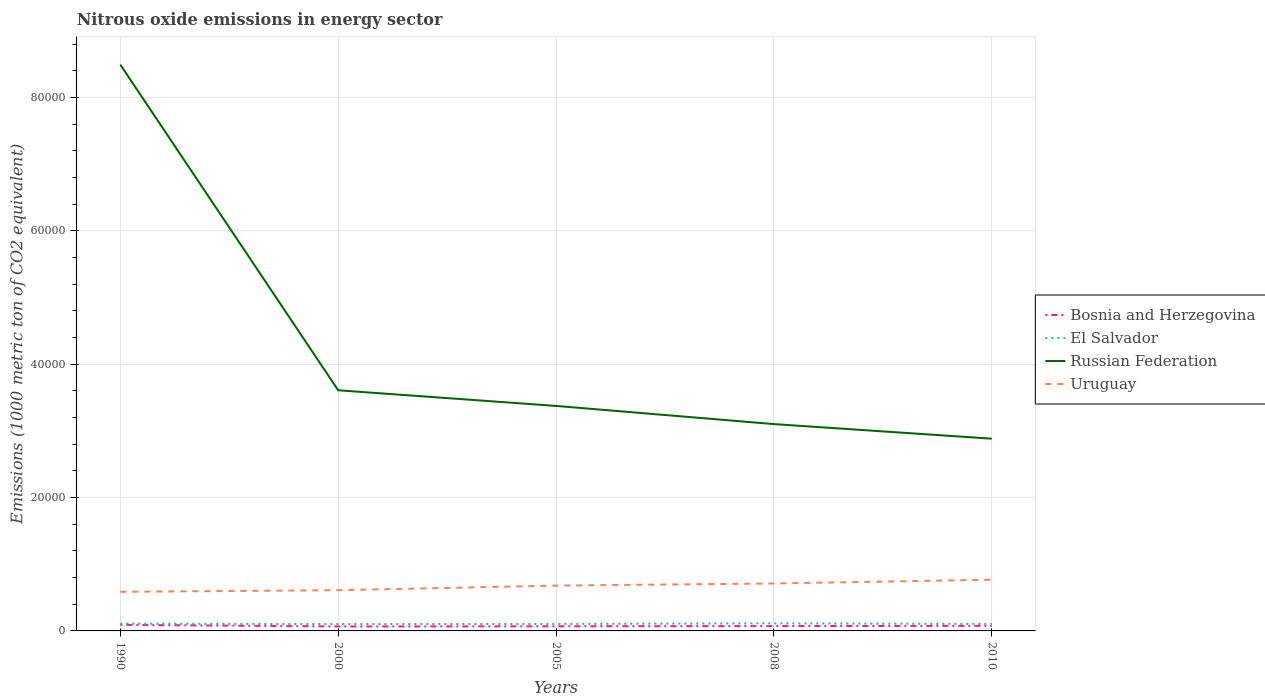Does the line corresponding to El Salvador intersect with the line corresponding to Bosnia and Herzegovina?
Provide a succinct answer. No. Across all years, what is the maximum amount of nitrous oxide emitted in El Salvador?
Ensure brevity in your answer.  1028. In which year was the amount of nitrous oxide emitted in Uruguay maximum?
Provide a succinct answer. 1990. What is the total amount of nitrous oxide emitted in Russian Federation in the graph?
Your response must be concise. 4.88e+04. What is the difference between the highest and the second highest amount of nitrous oxide emitted in El Salvador?
Provide a short and direct response. 107. How many lines are there?
Your response must be concise. 4. Does the graph contain any zero values?
Keep it short and to the point. No. What is the title of the graph?
Provide a short and direct response. Nitrous oxide emissions in energy sector. What is the label or title of the X-axis?
Provide a short and direct response. Years. What is the label or title of the Y-axis?
Keep it short and to the point. Emissions (1000 metric ton of CO2 equivalent). What is the Emissions (1000 metric ton of CO2 equivalent) of Bosnia and Herzegovina in 1990?
Offer a terse response. 912.2. What is the Emissions (1000 metric ton of CO2 equivalent) in El Salvador in 1990?
Provide a short and direct response. 1088.8. What is the Emissions (1000 metric ton of CO2 equivalent) of Russian Federation in 1990?
Keep it short and to the point. 8.49e+04. What is the Emissions (1000 metric ton of CO2 equivalent) of Uruguay in 1990?
Provide a short and direct response. 5867.6. What is the Emissions (1000 metric ton of CO2 equivalent) in Bosnia and Herzegovina in 2000?
Offer a very short reply. 669.3. What is the Emissions (1000 metric ton of CO2 equivalent) of El Salvador in 2000?
Ensure brevity in your answer.  1028. What is the Emissions (1000 metric ton of CO2 equivalent) of Russian Federation in 2000?
Your response must be concise. 3.61e+04. What is the Emissions (1000 metric ton of CO2 equivalent) in Uruguay in 2000?
Ensure brevity in your answer.  6109. What is the Emissions (1000 metric ton of CO2 equivalent) in Bosnia and Herzegovina in 2005?
Ensure brevity in your answer.  691.3. What is the Emissions (1000 metric ton of CO2 equivalent) in El Salvador in 2005?
Make the answer very short. 1049.1. What is the Emissions (1000 metric ton of CO2 equivalent) in Russian Federation in 2005?
Provide a succinct answer. 3.37e+04. What is the Emissions (1000 metric ton of CO2 equivalent) in Uruguay in 2005?
Offer a very short reply. 6798.2. What is the Emissions (1000 metric ton of CO2 equivalent) in Bosnia and Herzegovina in 2008?
Your response must be concise. 727.1. What is the Emissions (1000 metric ton of CO2 equivalent) of El Salvador in 2008?
Your answer should be compact. 1135. What is the Emissions (1000 metric ton of CO2 equivalent) of Russian Federation in 2008?
Provide a short and direct response. 3.10e+04. What is the Emissions (1000 metric ton of CO2 equivalent) in Uruguay in 2008?
Your answer should be compact. 7116. What is the Emissions (1000 metric ton of CO2 equivalent) in Bosnia and Herzegovina in 2010?
Offer a terse response. 762.6. What is the Emissions (1000 metric ton of CO2 equivalent) of El Salvador in 2010?
Make the answer very short. 1044.8. What is the Emissions (1000 metric ton of CO2 equivalent) of Russian Federation in 2010?
Your answer should be very brief. 2.88e+04. What is the Emissions (1000 metric ton of CO2 equivalent) in Uruguay in 2010?
Offer a very short reply. 7685.3. Across all years, what is the maximum Emissions (1000 metric ton of CO2 equivalent) in Bosnia and Herzegovina?
Ensure brevity in your answer.  912.2. Across all years, what is the maximum Emissions (1000 metric ton of CO2 equivalent) in El Salvador?
Make the answer very short. 1135. Across all years, what is the maximum Emissions (1000 metric ton of CO2 equivalent) of Russian Federation?
Provide a short and direct response. 8.49e+04. Across all years, what is the maximum Emissions (1000 metric ton of CO2 equivalent) of Uruguay?
Your answer should be compact. 7685.3. Across all years, what is the minimum Emissions (1000 metric ton of CO2 equivalent) of Bosnia and Herzegovina?
Your answer should be compact. 669.3. Across all years, what is the minimum Emissions (1000 metric ton of CO2 equivalent) of El Salvador?
Keep it short and to the point. 1028. Across all years, what is the minimum Emissions (1000 metric ton of CO2 equivalent) of Russian Federation?
Provide a succinct answer. 2.88e+04. Across all years, what is the minimum Emissions (1000 metric ton of CO2 equivalent) of Uruguay?
Offer a very short reply. 5867.6. What is the total Emissions (1000 metric ton of CO2 equivalent) in Bosnia and Herzegovina in the graph?
Give a very brief answer. 3762.5. What is the total Emissions (1000 metric ton of CO2 equivalent) of El Salvador in the graph?
Provide a succinct answer. 5345.7. What is the total Emissions (1000 metric ton of CO2 equivalent) in Russian Federation in the graph?
Your answer should be compact. 2.15e+05. What is the total Emissions (1000 metric ton of CO2 equivalent) of Uruguay in the graph?
Your response must be concise. 3.36e+04. What is the difference between the Emissions (1000 metric ton of CO2 equivalent) in Bosnia and Herzegovina in 1990 and that in 2000?
Ensure brevity in your answer.  242.9. What is the difference between the Emissions (1000 metric ton of CO2 equivalent) in El Salvador in 1990 and that in 2000?
Give a very brief answer. 60.8. What is the difference between the Emissions (1000 metric ton of CO2 equivalent) in Russian Federation in 1990 and that in 2000?
Keep it short and to the point. 4.88e+04. What is the difference between the Emissions (1000 metric ton of CO2 equivalent) of Uruguay in 1990 and that in 2000?
Provide a succinct answer. -241.4. What is the difference between the Emissions (1000 metric ton of CO2 equivalent) of Bosnia and Herzegovina in 1990 and that in 2005?
Keep it short and to the point. 220.9. What is the difference between the Emissions (1000 metric ton of CO2 equivalent) in El Salvador in 1990 and that in 2005?
Make the answer very short. 39.7. What is the difference between the Emissions (1000 metric ton of CO2 equivalent) in Russian Federation in 1990 and that in 2005?
Ensure brevity in your answer.  5.12e+04. What is the difference between the Emissions (1000 metric ton of CO2 equivalent) in Uruguay in 1990 and that in 2005?
Keep it short and to the point. -930.6. What is the difference between the Emissions (1000 metric ton of CO2 equivalent) of Bosnia and Herzegovina in 1990 and that in 2008?
Ensure brevity in your answer.  185.1. What is the difference between the Emissions (1000 metric ton of CO2 equivalent) of El Salvador in 1990 and that in 2008?
Your answer should be compact. -46.2. What is the difference between the Emissions (1000 metric ton of CO2 equivalent) of Russian Federation in 1990 and that in 2008?
Offer a terse response. 5.39e+04. What is the difference between the Emissions (1000 metric ton of CO2 equivalent) in Uruguay in 1990 and that in 2008?
Your answer should be compact. -1248.4. What is the difference between the Emissions (1000 metric ton of CO2 equivalent) of Bosnia and Herzegovina in 1990 and that in 2010?
Your answer should be very brief. 149.6. What is the difference between the Emissions (1000 metric ton of CO2 equivalent) in El Salvador in 1990 and that in 2010?
Ensure brevity in your answer.  44. What is the difference between the Emissions (1000 metric ton of CO2 equivalent) of Russian Federation in 1990 and that in 2010?
Keep it short and to the point. 5.61e+04. What is the difference between the Emissions (1000 metric ton of CO2 equivalent) in Uruguay in 1990 and that in 2010?
Offer a very short reply. -1817.7. What is the difference between the Emissions (1000 metric ton of CO2 equivalent) in Bosnia and Herzegovina in 2000 and that in 2005?
Provide a short and direct response. -22. What is the difference between the Emissions (1000 metric ton of CO2 equivalent) in El Salvador in 2000 and that in 2005?
Keep it short and to the point. -21.1. What is the difference between the Emissions (1000 metric ton of CO2 equivalent) in Russian Federation in 2000 and that in 2005?
Your response must be concise. 2347.2. What is the difference between the Emissions (1000 metric ton of CO2 equivalent) in Uruguay in 2000 and that in 2005?
Your answer should be compact. -689.2. What is the difference between the Emissions (1000 metric ton of CO2 equivalent) of Bosnia and Herzegovina in 2000 and that in 2008?
Offer a terse response. -57.8. What is the difference between the Emissions (1000 metric ton of CO2 equivalent) of El Salvador in 2000 and that in 2008?
Ensure brevity in your answer.  -107. What is the difference between the Emissions (1000 metric ton of CO2 equivalent) in Russian Federation in 2000 and that in 2008?
Give a very brief answer. 5072.4. What is the difference between the Emissions (1000 metric ton of CO2 equivalent) of Uruguay in 2000 and that in 2008?
Offer a terse response. -1007. What is the difference between the Emissions (1000 metric ton of CO2 equivalent) of Bosnia and Herzegovina in 2000 and that in 2010?
Your response must be concise. -93.3. What is the difference between the Emissions (1000 metric ton of CO2 equivalent) in El Salvador in 2000 and that in 2010?
Offer a terse response. -16.8. What is the difference between the Emissions (1000 metric ton of CO2 equivalent) in Russian Federation in 2000 and that in 2010?
Keep it short and to the point. 7261.9. What is the difference between the Emissions (1000 metric ton of CO2 equivalent) of Uruguay in 2000 and that in 2010?
Make the answer very short. -1576.3. What is the difference between the Emissions (1000 metric ton of CO2 equivalent) of Bosnia and Herzegovina in 2005 and that in 2008?
Your answer should be very brief. -35.8. What is the difference between the Emissions (1000 metric ton of CO2 equivalent) in El Salvador in 2005 and that in 2008?
Make the answer very short. -85.9. What is the difference between the Emissions (1000 metric ton of CO2 equivalent) in Russian Federation in 2005 and that in 2008?
Provide a succinct answer. 2725.2. What is the difference between the Emissions (1000 metric ton of CO2 equivalent) of Uruguay in 2005 and that in 2008?
Provide a succinct answer. -317.8. What is the difference between the Emissions (1000 metric ton of CO2 equivalent) in Bosnia and Herzegovina in 2005 and that in 2010?
Offer a terse response. -71.3. What is the difference between the Emissions (1000 metric ton of CO2 equivalent) of Russian Federation in 2005 and that in 2010?
Your response must be concise. 4914.7. What is the difference between the Emissions (1000 metric ton of CO2 equivalent) in Uruguay in 2005 and that in 2010?
Keep it short and to the point. -887.1. What is the difference between the Emissions (1000 metric ton of CO2 equivalent) in Bosnia and Herzegovina in 2008 and that in 2010?
Provide a succinct answer. -35.5. What is the difference between the Emissions (1000 metric ton of CO2 equivalent) in El Salvador in 2008 and that in 2010?
Keep it short and to the point. 90.2. What is the difference between the Emissions (1000 metric ton of CO2 equivalent) in Russian Federation in 2008 and that in 2010?
Your answer should be very brief. 2189.5. What is the difference between the Emissions (1000 metric ton of CO2 equivalent) in Uruguay in 2008 and that in 2010?
Keep it short and to the point. -569.3. What is the difference between the Emissions (1000 metric ton of CO2 equivalent) of Bosnia and Herzegovina in 1990 and the Emissions (1000 metric ton of CO2 equivalent) of El Salvador in 2000?
Provide a succinct answer. -115.8. What is the difference between the Emissions (1000 metric ton of CO2 equivalent) in Bosnia and Herzegovina in 1990 and the Emissions (1000 metric ton of CO2 equivalent) in Russian Federation in 2000?
Provide a short and direct response. -3.52e+04. What is the difference between the Emissions (1000 metric ton of CO2 equivalent) in Bosnia and Herzegovina in 1990 and the Emissions (1000 metric ton of CO2 equivalent) in Uruguay in 2000?
Make the answer very short. -5196.8. What is the difference between the Emissions (1000 metric ton of CO2 equivalent) in El Salvador in 1990 and the Emissions (1000 metric ton of CO2 equivalent) in Russian Federation in 2000?
Ensure brevity in your answer.  -3.50e+04. What is the difference between the Emissions (1000 metric ton of CO2 equivalent) of El Salvador in 1990 and the Emissions (1000 metric ton of CO2 equivalent) of Uruguay in 2000?
Provide a short and direct response. -5020.2. What is the difference between the Emissions (1000 metric ton of CO2 equivalent) in Russian Federation in 1990 and the Emissions (1000 metric ton of CO2 equivalent) in Uruguay in 2000?
Make the answer very short. 7.88e+04. What is the difference between the Emissions (1000 metric ton of CO2 equivalent) of Bosnia and Herzegovina in 1990 and the Emissions (1000 metric ton of CO2 equivalent) of El Salvador in 2005?
Offer a terse response. -136.9. What is the difference between the Emissions (1000 metric ton of CO2 equivalent) of Bosnia and Herzegovina in 1990 and the Emissions (1000 metric ton of CO2 equivalent) of Russian Federation in 2005?
Provide a short and direct response. -3.28e+04. What is the difference between the Emissions (1000 metric ton of CO2 equivalent) of Bosnia and Herzegovina in 1990 and the Emissions (1000 metric ton of CO2 equivalent) of Uruguay in 2005?
Your response must be concise. -5886. What is the difference between the Emissions (1000 metric ton of CO2 equivalent) of El Salvador in 1990 and the Emissions (1000 metric ton of CO2 equivalent) of Russian Federation in 2005?
Your answer should be very brief. -3.27e+04. What is the difference between the Emissions (1000 metric ton of CO2 equivalent) in El Salvador in 1990 and the Emissions (1000 metric ton of CO2 equivalent) in Uruguay in 2005?
Provide a short and direct response. -5709.4. What is the difference between the Emissions (1000 metric ton of CO2 equivalent) in Russian Federation in 1990 and the Emissions (1000 metric ton of CO2 equivalent) in Uruguay in 2005?
Give a very brief answer. 7.81e+04. What is the difference between the Emissions (1000 metric ton of CO2 equivalent) in Bosnia and Herzegovina in 1990 and the Emissions (1000 metric ton of CO2 equivalent) in El Salvador in 2008?
Your response must be concise. -222.8. What is the difference between the Emissions (1000 metric ton of CO2 equivalent) in Bosnia and Herzegovina in 1990 and the Emissions (1000 metric ton of CO2 equivalent) in Russian Federation in 2008?
Ensure brevity in your answer.  -3.01e+04. What is the difference between the Emissions (1000 metric ton of CO2 equivalent) of Bosnia and Herzegovina in 1990 and the Emissions (1000 metric ton of CO2 equivalent) of Uruguay in 2008?
Offer a terse response. -6203.8. What is the difference between the Emissions (1000 metric ton of CO2 equivalent) of El Salvador in 1990 and the Emissions (1000 metric ton of CO2 equivalent) of Russian Federation in 2008?
Provide a succinct answer. -2.99e+04. What is the difference between the Emissions (1000 metric ton of CO2 equivalent) of El Salvador in 1990 and the Emissions (1000 metric ton of CO2 equivalent) of Uruguay in 2008?
Keep it short and to the point. -6027.2. What is the difference between the Emissions (1000 metric ton of CO2 equivalent) of Russian Federation in 1990 and the Emissions (1000 metric ton of CO2 equivalent) of Uruguay in 2008?
Your answer should be compact. 7.78e+04. What is the difference between the Emissions (1000 metric ton of CO2 equivalent) of Bosnia and Herzegovina in 1990 and the Emissions (1000 metric ton of CO2 equivalent) of El Salvador in 2010?
Offer a very short reply. -132.6. What is the difference between the Emissions (1000 metric ton of CO2 equivalent) of Bosnia and Herzegovina in 1990 and the Emissions (1000 metric ton of CO2 equivalent) of Russian Federation in 2010?
Your answer should be compact. -2.79e+04. What is the difference between the Emissions (1000 metric ton of CO2 equivalent) in Bosnia and Herzegovina in 1990 and the Emissions (1000 metric ton of CO2 equivalent) in Uruguay in 2010?
Provide a succinct answer. -6773.1. What is the difference between the Emissions (1000 metric ton of CO2 equivalent) in El Salvador in 1990 and the Emissions (1000 metric ton of CO2 equivalent) in Russian Federation in 2010?
Make the answer very short. -2.77e+04. What is the difference between the Emissions (1000 metric ton of CO2 equivalent) in El Salvador in 1990 and the Emissions (1000 metric ton of CO2 equivalent) in Uruguay in 2010?
Your response must be concise. -6596.5. What is the difference between the Emissions (1000 metric ton of CO2 equivalent) of Russian Federation in 1990 and the Emissions (1000 metric ton of CO2 equivalent) of Uruguay in 2010?
Offer a terse response. 7.73e+04. What is the difference between the Emissions (1000 metric ton of CO2 equivalent) in Bosnia and Herzegovina in 2000 and the Emissions (1000 metric ton of CO2 equivalent) in El Salvador in 2005?
Provide a short and direct response. -379.8. What is the difference between the Emissions (1000 metric ton of CO2 equivalent) in Bosnia and Herzegovina in 2000 and the Emissions (1000 metric ton of CO2 equivalent) in Russian Federation in 2005?
Make the answer very short. -3.31e+04. What is the difference between the Emissions (1000 metric ton of CO2 equivalent) in Bosnia and Herzegovina in 2000 and the Emissions (1000 metric ton of CO2 equivalent) in Uruguay in 2005?
Ensure brevity in your answer.  -6128.9. What is the difference between the Emissions (1000 metric ton of CO2 equivalent) of El Salvador in 2000 and the Emissions (1000 metric ton of CO2 equivalent) of Russian Federation in 2005?
Keep it short and to the point. -3.27e+04. What is the difference between the Emissions (1000 metric ton of CO2 equivalent) in El Salvador in 2000 and the Emissions (1000 metric ton of CO2 equivalent) in Uruguay in 2005?
Ensure brevity in your answer.  -5770.2. What is the difference between the Emissions (1000 metric ton of CO2 equivalent) in Russian Federation in 2000 and the Emissions (1000 metric ton of CO2 equivalent) in Uruguay in 2005?
Keep it short and to the point. 2.93e+04. What is the difference between the Emissions (1000 metric ton of CO2 equivalent) of Bosnia and Herzegovina in 2000 and the Emissions (1000 metric ton of CO2 equivalent) of El Salvador in 2008?
Your answer should be compact. -465.7. What is the difference between the Emissions (1000 metric ton of CO2 equivalent) of Bosnia and Herzegovina in 2000 and the Emissions (1000 metric ton of CO2 equivalent) of Russian Federation in 2008?
Provide a short and direct response. -3.04e+04. What is the difference between the Emissions (1000 metric ton of CO2 equivalent) of Bosnia and Herzegovina in 2000 and the Emissions (1000 metric ton of CO2 equivalent) of Uruguay in 2008?
Keep it short and to the point. -6446.7. What is the difference between the Emissions (1000 metric ton of CO2 equivalent) of El Salvador in 2000 and the Emissions (1000 metric ton of CO2 equivalent) of Russian Federation in 2008?
Offer a terse response. -3.00e+04. What is the difference between the Emissions (1000 metric ton of CO2 equivalent) in El Salvador in 2000 and the Emissions (1000 metric ton of CO2 equivalent) in Uruguay in 2008?
Give a very brief answer. -6088. What is the difference between the Emissions (1000 metric ton of CO2 equivalent) of Russian Federation in 2000 and the Emissions (1000 metric ton of CO2 equivalent) of Uruguay in 2008?
Keep it short and to the point. 2.90e+04. What is the difference between the Emissions (1000 metric ton of CO2 equivalent) in Bosnia and Herzegovina in 2000 and the Emissions (1000 metric ton of CO2 equivalent) in El Salvador in 2010?
Give a very brief answer. -375.5. What is the difference between the Emissions (1000 metric ton of CO2 equivalent) of Bosnia and Herzegovina in 2000 and the Emissions (1000 metric ton of CO2 equivalent) of Russian Federation in 2010?
Offer a very short reply. -2.82e+04. What is the difference between the Emissions (1000 metric ton of CO2 equivalent) of Bosnia and Herzegovina in 2000 and the Emissions (1000 metric ton of CO2 equivalent) of Uruguay in 2010?
Offer a very short reply. -7016. What is the difference between the Emissions (1000 metric ton of CO2 equivalent) in El Salvador in 2000 and the Emissions (1000 metric ton of CO2 equivalent) in Russian Federation in 2010?
Your answer should be very brief. -2.78e+04. What is the difference between the Emissions (1000 metric ton of CO2 equivalent) in El Salvador in 2000 and the Emissions (1000 metric ton of CO2 equivalent) in Uruguay in 2010?
Your answer should be very brief. -6657.3. What is the difference between the Emissions (1000 metric ton of CO2 equivalent) of Russian Federation in 2000 and the Emissions (1000 metric ton of CO2 equivalent) of Uruguay in 2010?
Keep it short and to the point. 2.84e+04. What is the difference between the Emissions (1000 metric ton of CO2 equivalent) of Bosnia and Herzegovina in 2005 and the Emissions (1000 metric ton of CO2 equivalent) of El Salvador in 2008?
Provide a short and direct response. -443.7. What is the difference between the Emissions (1000 metric ton of CO2 equivalent) of Bosnia and Herzegovina in 2005 and the Emissions (1000 metric ton of CO2 equivalent) of Russian Federation in 2008?
Provide a succinct answer. -3.03e+04. What is the difference between the Emissions (1000 metric ton of CO2 equivalent) of Bosnia and Herzegovina in 2005 and the Emissions (1000 metric ton of CO2 equivalent) of Uruguay in 2008?
Offer a terse response. -6424.7. What is the difference between the Emissions (1000 metric ton of CO2 equivalent) in El Salvador in 2005 and the Emissions (1000 metric ton of CO2 equivalent) in Russian Federation in 2008?
Provide a short and direct response. -3.00e+04. What is the difference between the Emissions (1000 metric ton of CO2 equivalent) of El Salvador in 2005 and the Emissions (1000 metric ton of CO2 equivalent) of Uruguay in 2008?
Make the answer very short. -6066.9. What is the difference between the Emissions (1000 metric ton of CO2 equivalent) in Russian Federation in 2005 and the Emissions (1000 metric ton of CO2 equivalent) in Uruguay in 2008?
Your answer should be compact. 2.66e+04. What is the difference between the Emissions (1000 metric ton of CO2 equivalent) of Bosnia and Herzegovina in 2005 and the Emissions (1000 metric ton of CO2 equivalent) of El Salvador in 2010?
Keep it short and to the point. -353.5. What is the difference between the Emissions (1000 metric ton of CO2 equivalent) of Bosnia and Herzegovina in 2005 and the Emissions (1000 metric ton of CO2 equivalent) of Russian Federation in 2010?
Keep it short and to the point. -2.81e+04. What is the difference between the Emissions (1000 metric ton of CO2 equivalent) of Bosnia and Herzegovina in 2005 and the Emissions (1000 metric ton of CO2 equivalent) of Uruguay in 2010?
Offer a terse response. -6994. What is the difference between the Emissions (1000 metric ton of CO2 equivalent) in El Salvador in 2005 and the Emissions (1000 metric ton of CO2 equivalent) in Russian Federation in 2010?
Offer a very short reply. -2.78e+04. What is the difference between the Emissions (1000 metric ton of CO2 equivalent) in El Salvador in 2005 and the Emissions (1000 metric ton of CO2 equivalent) in Uruguay in 2010?
Make the answer very short. -6636.2. What is the difference between the Emissions (1000 metric ton of CO2 equivalent) in Russian Federation in 2005 and the Emissions (1000 metric ton of CO2 equivalent) in Uruguay in 2010?
Give a very brief answer. 2.61e+04. What is the difference between the Emissions (1000 metric ton of CO2 equivalent) in Bosnia and Herzegovina in 2008 and the Emissions (1000 metric ton of CO2 equivalent) in El Salvador in 2010?
Your answer should be very brief. -317.7. What is the difference between the Emissions (1000 metric ton of CO2 equivalent) of Bosnia and Herzegovina in 2008 and the Emissions (1000 metric ton of CO2 equivalent) of Russian Federation in 2010?
Provide a short and direct response. -2.81e+04. What is the difference between the Emissions (1000 metric ton of CO2 equivalent) in Bosnia and Herzegovina in 2008 and the Emissions (1000 metric ton of CO2 equivalent) in Uruguay in 2010?
Make the answer very short. -6958.2. What is the difference between the Emissions (1000 metric ton of CO2 equivalent) in El Salvador in 2008 and the Emissions (1000 metric ton of CO2 equivalent) in Russian Federation in 2010?
Make the answer very short. -2.77e+04. What is the difference between the Emissions (1000 metric ton of CO2 equivalent) in El Salvador in 2008 and the Emissions (1000 metric ton of CO2 equivalent) in Uruguay in 2010?
Offer a very short reply. -6550.3. What is the difference between the Emissions (1000 metric ton of CO2 equivalent) of Russian Federation in 2008 and the Emissions (1000 metric ton of CO2 equivalent) of Uruguay in 2010?
Ensure brevity in your answer.  2.33e+04. What is the average Emissions (1000 metric ton of CO2 equivalent) of Bosnia and Herzegovina per year?
Your answer should be compact. 752.5. What is the average Emissions (1000 metric ton of CO2 equivalent) of El Salvador per year?
Your response must be concise. 1069.14. What is the average Emissions (1000 metric ton of CO2 equivalent) of Russian Federation per year?
Your response must be concise. 4.29e+04. What is the average Emissions (1000 metric ton of CO2 equivalent) of Uruguay per year?
Offer a very short reply. 6715.22. In the year 1990, what is the difference between the Emissions (1000 metric ton of CO2 equivalent) in Bosnia and Herzegovina and Emissions (1000 metric ton of CO2 equivalent) in El Salvador?
Your answer should be compact. -176.6. In the year 1990, what is the difference between the Emissions (1000 metric ton of CO2 equivalent) in Bosnia and Herzegovina and Emissions (1000 metric ton of CO2 equivalent) in Russian Federation?
Your response must be concise. -8.40e+04. In the year 1990, what is the difference between the Emissions (1000 metric ton of CO2 equivalent) of Bosnia and Herzegovina and Emissions (1000 metric ton of CO2 equivalent) of Uruguay?
Your response must be concise. -4955.4. In the year 1990, what is the difference between the Emissions (1000 metric ton of CO2 equivalent) of El Salvador and Emissions (1000 metric ton of CO2 equivalent) of Russian Federation?
Keep it short and to the point. -8.38e+04. In the year 1990, what is the difference between the Emissions (1000 metric ton of CO2 equivalent) of El Salvador and Emissions (1000 metric ton of CO2 equivalent) of Uruguay?
Ensure brevity in your answer.  -4778.8. In the year 1990, what is the difference between the Emissions (1000 metric ton of CO2 equivalent) in Russian Federation and Emissions (1000 metric ton of CO2 equivalent) in Uruguay?
Your response must be concise. 7.91e+04. In the year 2000, what is the difference between the Emissions (1000 metric ton of CO2 equivalent) of Bosnia and Herzegovina and Emissions (1000 metric ton of CO2 equivalent) of El Salvador?
Ensure brevity in your answer.  -358.7. In the year 2000, what is the difference between the Emissions (1000 metric ton of CO2 equivalent) of Bosnia and Herzegovina and Emissions (1000 metric ton of CO2 equivalent) of Russian Federation?
Your response must be concise. -3.54e+04. In the year 2000, what is the difference between the Emissions (1000 metric ton of CO2 equivalent) of Bosnia and Herzegovina and Emissions (1000 metric ton of CO2 equivalent) of Uruguay?
Offer a terse response. -5439.7. In the year 2000, what is the difference between the Emissions (1000 metric ton of CO2 equivalent) of El Salvador and Emissions (1000 metric ton of CO2 equivalent) of Russian Federation?
Keep it short and to the point. -3.51e+04. In the year 2000, what is the difference between the Emissions (1000 metric ton of CO2 equivalent) of El Salvador and Emissions (1000 metric ton of CO2 equivalent) of Uruguay?
Your response must be concise. -5081. In the year 2000, what is the difference between the Emissions (1000 metric ton of CO2 equivalent) of Russian Federation and Emissions (1000 metric ton of CO2 equivalent) of Uruguay?
Offer a terse response. 3.00e+04. In the year 2005, what is the difference between the Emissions (1000 metric ton of CO2 equivalent) of Bosnia and Herzegovina and Emissions (1000 metric ton of CO2 equivalent) of El Salvador?
Your answer should be compact. -357.8. In the year 2005, what is the difference between the Emissions (1000 metric ton of CO2 equivalent) of Bosnia and Herzegovina and Emissions (1000 metric ton of CO2 equivalent) of Russian Federation?
Keep it short and to the point. -3.31e+04. In the year 2005, what is the difference between the Emissions (1000 metric ton of CO2 equivalent) of Bosnia and Herzegovina and Emissions (1000 metric ton of CO2 equivalent) of Uruguay?
Offer a very short reply. -6106.9. In the year 2005, what is the difference between the Emissions (1000 metric ton of CO2 equivalent) of El Salvador and Emissions (1000 metric ton of CO2 equivalent) of Russian Federation?
Your response must be concise. -3.27e+04. In the year 2005, what is the difference between the Emissions (1000 metric ton of CO2 equivalent) in El Salvador and Emissions (1000 metric ton of CO2 equivalent) in Uruguay?
Make the answer very short. -5749.1. In the year 2005, what is the difference between the Emissions (1000 metric ton of CO2 equivalent) of Russian Federation and Emissions (1000 metric ton of CO2 equivalent) of Uruguay?
Give a very brief answer. 2.70e+04. In the year 2008, what is the difference between the Emissions (1000 metric ton of CO2 equivalent) in Bosnia and Herzegovina and Emissions (1000 metric ton of CO2 equivalent) in El Salvador?
Provide a short and direct response. -407.9. In the year 2008, what is the difference between the Emissions (1000 metric ton of CO2 equivalent) of Bosnia and Herzegovina and Emissions (1000 metric ton of CO2 equivalent) of Russian Federation?
Ensure brevity in your answer.  -3.03e+04. In the year 2008, what is the difference between the Emissions (1000 metric ton of CO2 equivalent) in Bosnia and Herzegovina and Emissions (1000 metric ton of CO2 equivalent) in Uruguay?
Offer a very short reply. -6388.9. In the year 2008, what is the difference between the Emissions (1000 metric ton of CO2 equivalent) in El Salvador and Emissions (1000 metric ton of CO2 equivalent) in Russian Federation?
Ensure brevity in your answer.  -2.99e+04. In the year 2008, what is the difference between the Emissions (1000 metric ton of CO2 equivalent) of El Salvador and Emissions (1000 metric ton of CO2 equivalent) of Uruguay?
Ensure brevity in your answer.  -5981. In the year 2008, what is the difference between the Emissions (1000 metric ton of CO2 equivalent) of Russian Federation and Emissions (1000 metric ton of CO2 equivalent) of Uruguay?
Keep it short and to the point. 2.39e+04. In the year 2010, what is the difference between the Emissions (1000 metric ton of CO2 equivalent) of Bosnia and Herzegovina and Emissions (1000 metric ton of CO2 equivalent) of El Salvador?
Provide a short and direct response. -282.2. In the year 2010, what is the difference between the Emissions (1000 metric ton of CO2 equivalent) of Bosnia and Herzegovina and Emissions (1000 metric ton of CO2 equivalent) of Russian Federation?
Provide a succinct answer. -2.81e+04. In the year 2010, what is the difference between the Emissions (1000 metric ton of CO2 equivalent) in Bosnia and Herzegovina and Emissions (1000 metric ton of CO2 equivalent) in Uruguay?
Keep it short and to the point. -6922.7. In the year 2010, what is the difference between the Emissions (1000 metric ton of CO2 equivalent) of El Salvador and Emissions (1000 metric ton of CO2 equivalent) of Russian Federation?
Make the answer very short. -2.78e+04. In the year 2010, what is the difference between the Emissions (1000 metric ton of CO2 equivalent) in El Salvador and Emissions (1000 metric ton of CO2 equivalent) in Uruguay?
Provide a short and direct response. -6640.5. In the year 2010, what is the difference between the Emissions (1000 metric ton of CO2 equivalent) in Russian Federation and Emissions (1000 metric ton of CO2 equivalent) in Uruguay?
Keep it short and to the point. 2.11e+04. What is the ratio of the Emissions (1000 metric ton of CO2 equivalent) of Bosnia and Herzegovina in 1990 to that in 2000?
Offer a terse response. 1.36. What is the ratio of the Emissions (1000 metric ton of CO2 equivalent) of El Salvador in 1990 to that in 2000?
Give a very brief answer. 1.06. What is the ratio of the Emissions (1000 metric ton of CO2 equivalent) in Russian Federation in 1990 to that in 2000?
Give a very brief answer. 2.35. What is the ratio of the Emissions (1000 metric ton of CO2 equivalent) in Uruguay in 1990 to that in 2000?
Offer a terse response. 0.96. What is the ratio of the Emissions (1000 metric ton of CO2 equivalent) of Bosnia and Herzegovina in 1990 to that in 2005?
Provide a short and direct response. 1.32. What is the ratio of the Emissions (1000 metric ton of CO2 equivalent) of El Salvador in 1990 to that in 2005?
Keep it short and to the point. 1.04. What is the ratio of the Emissions (1000 metric ton of CO2 equivalent) of Russian Federation in 1990 to that in 2005?
Your answer should be very brief. 2.52. What is the ratio of the Emissions (1000 metric ton of CO2 equivalent) of Uruguay in 1990 to that in 2005?
Keep it short and to the point. 0.86. What is the ratio of the Emissions (1000 metric ton of CO2 equivalent) in Bosnia and Herzegovina in 1990 to that in 2008?
Provide a short and direct response. 1.25. What is the ratio of the Emissions (1000 metric ton of CO2 equivalent) of El Salvador in 1990 to that in 2008?
Offer a terse response. 0.96. What is the ratio of the Emissions (1000 metric ton of CO2 equivalent) of Russian Federation in 1990 to that in 2008?
Provide a short and direct response. 2.74. What is the ratio of the Emissions (1000 metric ton of CO2 equivalent) in Uruguay in 1990 to that in 2008?
Offer a terse response. 0.82. What is the ratio of the Emissions (1000 metric ton of CO2 equivalent) in Bosnia and Herzegovina in 1990 to that in 2010?
Your answer should be compact. 1.2. What is the ratio of the Emissions (1000 metric ton of CO2 equivalent) in El Salvador in 1990 to that in 2010?
Your answer should be compact. 1.04. What is the ratio of the Emissions (1000 metric ton of CO2 equivalent) in Russian Federation in 1990 to that in 2010?
Give a very brief answer. 2.95. What is the ratio of the Emissions (1000 metric ton of CO2 equivalent) in Uruguay in 1990 to that in 2010?
Give a very brief answer. 0.76. What is the ratio of the Emissions (1000 metric ton of CO2 equivalent) in Bosnia and Herzegovina in 2000 to that in 2005?
Provide a succinct answer. 0.97. What is the ratio of the Emissions (1000 metric ton of CO2 equivalent) of El Salvador in 2000 to that in 2005?
Offer a very short reply. 0.98. What is the ratio of the Emissions (1000 metric ton of CO2 equivalent) in Russian Federation in 2000 to that in 2005?
Provide a succinct answer. 1.07. What is the ratio of the Emissions (1000 metric ton of CO2 equivalent) of Uruguay in 2000 to that in 2005?
Keep it short and to the point. 0.9. What is the ratio of the Emissions (1000 metric ton of CO2 equivalent) of Bosnia and Herzegovina in 2000 to that in 2008?
Offer a terse response. 0.92. What is the ratio of the Emissions (1000 metric ton of CO2 equivalent) in El Salvador in 2000 to that in 2008?
Your answer should be very brief. 0.91. What is the ratio of the Emissions (1000 metric ton of CO2 equivalent) in Russian Federation in 2000 to that in 2008?
Your response must be concise. 1.16. What is the ratio of the Emissions (1000 metric ton of CO2 equivalent) of Uruguay in 2000 to that in 2008?
Your response must be concise. 0.86. What is the ratio of the Emissions (1000 metric ton of CO2 equivalent) in Bosnia and Herzegovina in 2000 to that in 2010?
Provide a short and direct response. 0.88. What is the ratio of the Emissions (1000 metric ton of CO2 equivalent) of El Salvador in 2000 to that in 2010?
Offer a terse response. 0.98. What is the ratio of the Emissions (1000 metric ton of CO2 equivalent) in Russian Federation in 2000 to that in 2010?
Give a very brief answer. 1.25. What is the ratio of the Emissions (1000 metric ton of CO2 equivalent) of Uruguay in 2000 to that in 2010?
Offer a terse response. 0.79. What is the ratio of the Emissions (1000 metric ton of CO2 equivalent) in Bosnia and Herzegovina in 2005 to that in 2008?
Your answer should be compact. 0.95. What is the ratio of the Emissions (1000 metric ton of CO2 equivalent) in El Salvador in 2005 to that in 2008?
Give a very brief answer. 0.92. What is the ratio of the Emissions (1000 metric ton of CO2 equivalent) in Russian Federation in 2005 to that in 2008?
Provide a short and direct response. 1.09. What is the ratio of the Emissions (1000 metric ton of CO2 equivalent) in Uruguay in 2005 to that in 2008?
Keep it short and to the point. 0.96. What is the ratio of the Emissions (1000 metric ton of CO2 equivalent) in Bosnia and Herzegovina in 2005 to that in 2010?
Offer a terse response. 0.91. What is the ratio of the Emissions (1000 metric ton of CO2 equivalent) of Russian Federation in 2005 to that in 2010?
Provide a succinct answer. 1.17. What is the ratio of the Emissions (1000 metric ton of CO2 equivalent) of Uruguay in 2005 to that in 2010?
Offer a very short reply. 0.88. What is the ratio of the Emissions (1000 metric ton of CO2 equivalent) of Bosnia and Herzegovina in 2008 to that in 2010?
Offer a terse response. 0.95. What is the ratio of the Emissions (1000 metric ton of CO2 equivalent) in El Salvador in 2008 to that in 2010?
Your answer should be compact. 1.09. What is the ratio of the Emissions (1000 metric ton of CO2 equivalent) of Russian Federation in 2008 to that in 2010?
Provide a short and direct response. 1.08. What is the ratio of the Emissions (1000 metric ton of CO2 equivalent) in Uruguay in 2008 to that in 2010?
Offer a very short reply. 0.93. What is the difference between the highest and the second highest Emissions (1000 metric ton of CO2 equivalent) of Bosnia and Herzegovina?
Keep it short and to the point. 149.6. What is the difference between the highest and the second highest Emissions (1000 metric ton of CO2 equivalent) of El Salvador?
Provide a succinct answer. 46.2. What is the difference between the highest and the second highest Emissions (1000 metric ton of CO2 equivalent) in Russian Federation?
Your answer should be compact. 4.88e+04. What is the difference between the highest and the second highest Emissions (1000 metric ton of CO2 equivalent) of Uruguay?
Your answer should be very brief. 569.3. What is the difference between the highest and the lowest Emissions (1000 metric ton of CO2 equivalent) in Bosnia and Herzegovina?
Offer a terse response. 242.9. What is the difference between the highest and the lowest Emissions (1000 metric ton of CO2 equivalent) in El Salvador?
Your answer should be very brief. 107. What is the difference between the highest and the lowest Emissions (1000 metric ton of CO2 equivalent) in Russian Federation?
Your response must be concise. 5.61e+04. What is the difference between the highest and the lowest Emissions (1000 metric ton of CO2 equivalent) in Uruguay?
Provide a short and direct response. 1817.7. 